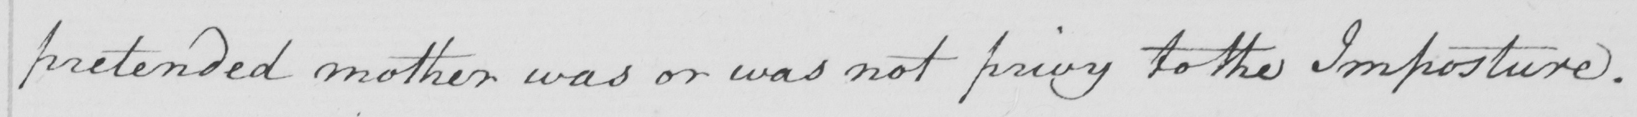Please provide the text content of this handwritten line. pretended mother was or was not privy to the Imposture . 